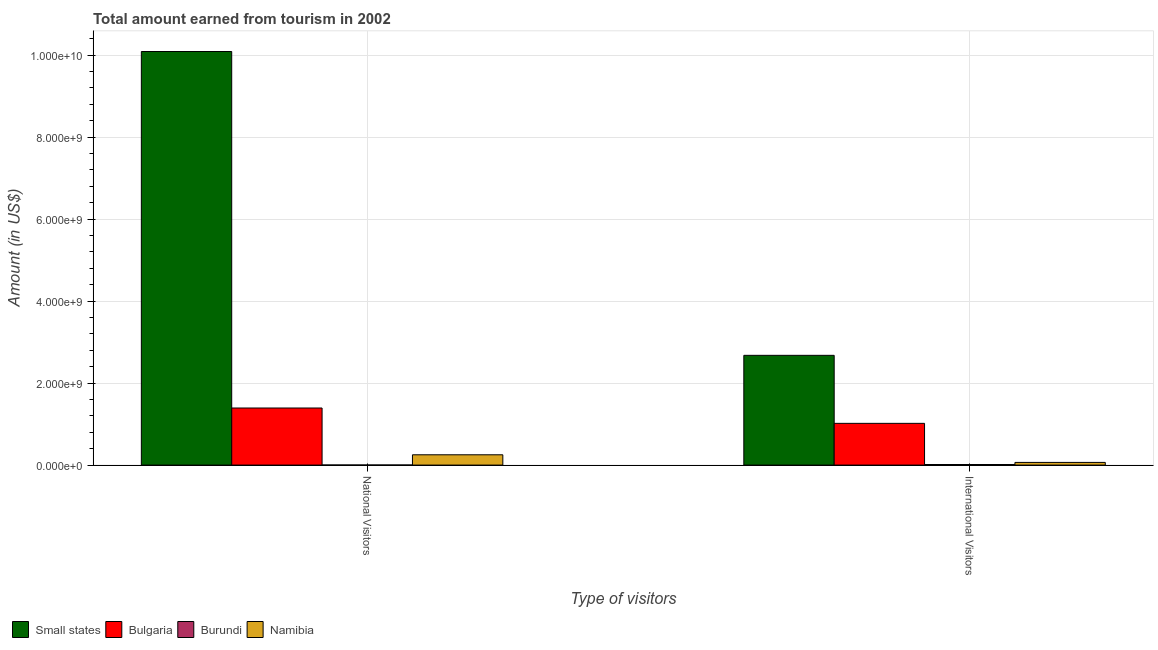How many different coloured bars are there?
Ensure brevity in your answer.  4. Are the number of bars per tick equal to the number of legend labels?
Offer a terse response. Yes. Are the number of bars on each tick of the X-axis equal?
Your answer should be compact. Yes. How many bars are there on the 2nd tick from the right?
Your response must be concise. 4. What is the label of the 2nd group of bars from the left?
Ensure brevity in your answer.  International Visitors. What is the amount earned from national visitors in Namibia?
Provide a short and direct response. 2.51e+08. Across all countries, what is the maximum amount earned from national visitors?
Your answer should be compact. 1.01e+1. Across all countries, what is the minimum amount earned from international visitors?
Your answer should be very brief. 1.40e+07. In which country was the amount earned from national visitors maximum?
Offer a terse response. Small states. In which country was the amount earned from national visitors minimum?
Ensure brevity in your answer.  Burundi. What is the total amount earned from national visitors in the graph?
Provide a short and direct response. 1.17e+1. What is the difference between the amount earned from international visitors in Burundi and that in Namibia?
Make the answer very short. -5.10e+07. What is the difference between the amount earned from international visitors in Namibia and the amount earned from national visitors in Burundi?
Keep it short and to the point. 6.34e+07. What is the average amount earned from national visitors per country?
Your answer should be compact. 2.93e+09. What is the difference between the amount earned from international visitors and amount earned from national visitors in Burundi?
Your response must be concise. 1.24e+07. What is the ratio of the amount earned from national visitors in Namibia to that in Burundi?
Provide a short and direct response. 156.88. Is the amount earned from national visitors in Bulgaria less than that in Small states?
Keep it short and to the point. Yes. In how many countries, is the amount earned from international visitors greater than the average amount earned from international visitors taken over all countries?
Make the answer very short. 2. What does the 2nd bar from the left in International Visitors represents?
Ensure brevity in your answer.  Bulgaria. What does the 2nd bar from the right in National Visitors represents?
Give a very brief answer. Burundi. Are all the bars in the graph horizontal?
Your answer should be very brief. No. What is the difference between two consecutive major ticks on the Y-axis?
Make the answer very short. 2.00e+09. Are the values on the major ticks of Y-axis written in scientific E-notation?
Your answer should be compact. Yes. How many legend labels are there?
Provide a short and direct response. 4. What is the title of the graph?
Make the answer very short. Total amount earned from tourism in 2002. What is the label or title of the X-axis?
Give a very brief answer. Type of visitors. What is the Amount (in US$) of Small states in National Visitors?
Your answer should be compact. 1.01e+1. What is the Amount (in US$) of Bulgaria in National Visitors?
Provide a short and direct response. 1.39e+09. What is the Amount (in US$) of Burundi in National Visitors?
Make the answer very short. 1.60e+06. What is the Amount (in US$) in Namibia in National Visitors?
Provide a short and direct response. 2.51e+08. What is the Amount (in US$) in Small states in International Visitors?
Offer a very short reply. 2.68e+09. What is the Amount (in US$) of Bulgaria in International Visitors?
Your response must be concise. 1.02e+09. What is the Amount (in US$) of Burundi in International Visitors?
Keep it short and to the point. 1.40e+07. What is the Amount (in US$) of Namibia in International Visitors?
Provide a short and direct response. 6.50e+07. Across all Type of visitors, what is the maximum Amount (in US$) of Small states?
Offer a very short reply. 1.01e+1. Across all Type of visitors, what is the maximum Amount (in US$) of Bulgaria?
Keep it short and to the point. 1.39e+09. Across all Type of visitors, what is the maximum Amount (in US$) of Burundi?
Offer a very short reply. 1.40e+07. Across all Type of visitors, what is the maximum Amount (in US$) of Namibia?
Your response must be concise. 2.51e+08. Across all Type of visitors, what is the minimum Amount (in US$) in Small states?
Your answer should be very brief. 2.68e+09. Across all Type of visitors, what is the minimum Amount (in US$) of Bulgaria?
Keep it short and to the point. 1.02e+09. Across all Type of visitors, what is the minimum Amount (in US$) in Burundi?
Your response must be concise. 1.60e+06. Across all Type of visitors, what is the minimum Amount (in US$) of Namibia?
Provide a short and direct response. 6.50e+07. What is the total Amount (in US$) of Small states in the graph?
Offer a very short reply. 1.28e+1. What is the total Amount (in US$) in Bulgaria in the graph?
Your response must be concise. 2.41e+09. What is the total Amount (in US$) of Burundi in the graph?
Your response must be concise. 1.56e+07. What is the total Amount (in US$) of Namibia in the graph?
Offer a terse response. 3.16e+08. What is the difference between the Amount (in US$) in Small states in National Visitors and that in International Visitors?
Provide a short and direct response. 7.41e+09. What is the difference between the Amount (in US$) of Bulgaria in National Visitors and that in International Visitors?
Offer a terse response. 3.74e+08. What is the difference between the Amount (in US$) of Burundi in National Visitors and that in International Visitors?
Your response must be concise. -1.24e+07. What is the difference between the Amount (in US$) of Namibia in National Visitors and that in International Visitors?
Provide a succinct answer. 1.86e+08. What is the difference between the Amount (in US$) in Small states in National Visitors and the Amount (in US$) in Bulgaria in International Visitors?
Offer a terse response. 9.07e+09. What is the difference between the Amount (in US$) of Small states in National Visitors and the Amount (in US$) of Burundi in International Visitors?
Your answer should be very brief. 1.01e+1. What is the difference between the Amount (in US$) of Small states in National Visitors and the Amount (in US$) of Namibia in International Visitors?
Provide a succinct answer. 1.00e+1. What is the difference between the Amount (in US$) in Bulgaria in National Visitors and the Amount (in US$) in Burundi in International Visitors?
Provide a succinct answer. 1.38e+09. What is the difference between the Amount (in US$) in Bulgaria in National Visitors and the Amount (in US$) in Namibia in International Visitors?
Provide a short and direct response. 1.33e+09. What is the difference between the Amount (in US$) in Burundi in National Visitors and the Amount (in US$) in Namibia in International Visitors?
Offer a very short reply. -6.34e+07. What is the average Amount (in US$) in Small states per Type of visitors?
Your response must be concise. 6.38e+09. What is the average Amount (in US$) in Bulgaria per Type of visitors?
Ensure brevity in your answer.  1.20e+09. What is the average Amount (in US$) in Burundi per Type of visitors?
Ensure brevity in your answer.  7.80e+06. What is the average Amount (in US$) in Namibia per Type of visitors?
Keep it short and to the point. 1.58e+08. What is the difference between the Amount (in US$) in Small states and Amount (in US$) in Bulgaria in National Visitors?
Offer a very short reply. 8.70e+09. What is the difference between the Amount (in US$) of Small states and Amount (in US$) of Burundi in National Visitors?
Keep it short and to the point. 1.01e+1. What is the difference between the Amount (in US$) in Small states and Amount (in US$) in Namibia in National Visitors?
Provide a succinct answer. 9.84e+09. What is the difference between the Amount (in US$) in Bulgaria and Amount (in US$) in Burundi in National Visitors?
Your answer should be compact. 1.39e+09. What is the difference between the Amount (in US$) of Bulgaria and Amount (in US$) of Namibia in National Visitors?
Provide a short and direct response. 1.14e+09. What is the difference between the Amount (in US$) in Burundi and Amount (in US$) in Namibia in National Visitors?
Your response must be concise. -2.49e+08. What is the difference between the Amount (in US$) of Small states and Amount (in US$) of Bulgaria in International Visitors?
Provide a succinct answer. 1.66e+09. What is the difference between the Amount (in US$) in Small states and Amount (in US$) in Burundi in International Visitors?
Offer a very short reply. 2.66e+09. What is the difference between the Amount (in US$) in Small states and Amount (in US$) in Namibia in International Visitors?
Provide a short and direct response. 2.61e+09. What is the difference between the Amount (in US$) of Bulgaria and Amount (in US$) of Burundi in International Visitors?
Your answer should be compact. 1.00e+09. What is the difference between the Amount (in US$) in Bulgaria and Amount (in US$) in Namibia in International Visitors?
Ensure brevity in your answer.  9.53e+08. What is the difference between the Amount (in US$) of Burundi and Amount (in US$) of Namibia in International Visitors?
Give a very brief answer. -5.10e+07. What is the ratio of the Amount (in US$) of Small states in National Visitors to that in International Visitors?
Ensure brevity in your answer.  3.77. What is the ratio of the Amount (in US$) in Bulgaria in National Visitors to that in International Visitors?
Ensure brevity in your answer.  1.37. What is the ratio of the Amount (in US$) of Burundi in National Visitors to that in International Visitors?
Offer a very short reply. 0.11. What is the ratio of the Amount (in US$) in Namibia in National Visitors to that in International Visitors?
Offer a very short reply. 3.86. What is the difference between the highest and the second highest Amount (in US$) of Small states?
Offer a terse response. 7.41e+09. What is the difference between the highest and the second highest Amount (in US$) of Bulgaria?
Ensure brevity in your answer.  3.74e+08. What is the difference between the highest and the second highest Amount (in US$) of Burundi?
Ensure brevity in your answer.  1.24e+07. What is the difference between the highest and the second highest Amount (in US$) in Namibia?
Keep it short and to the point. 1.86e+08. What is the difference between the highest and the lowest Amount (in US$) of Small states?
Provide a succinct answer. 7.41e+09. What is the difference between the highest and the lowest Amount (in US$) of Bulgaria?
Keep it short and to the point. 3.74e+08. What is the difference between the highest and the lowest Amount (in US$) in Burundi?
Provide a succinct answer. 1.24e+07. What is the difference between the highest and the lowest Amount (in US$) in Namibia?
Give a very brief answer. 1.86e+08. 